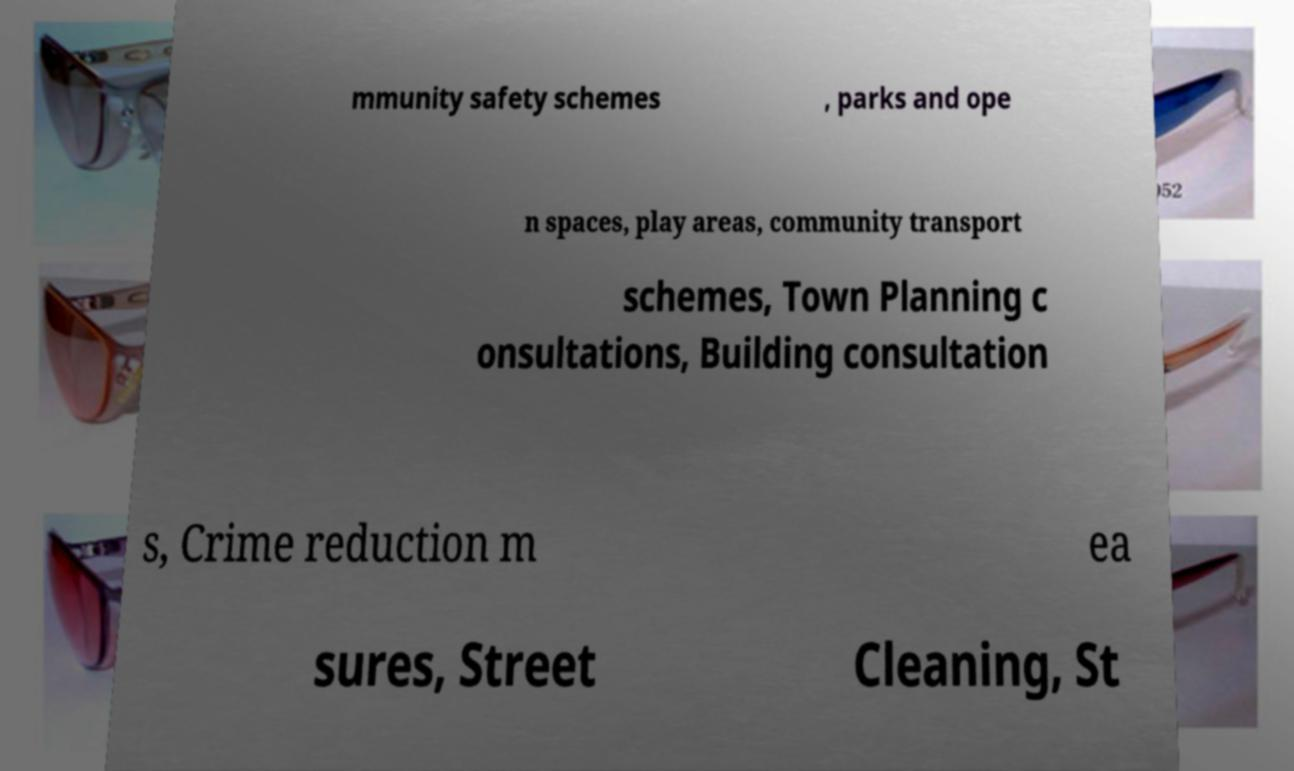Could you assist in decoding the text presented in this image and type it out clearly? mmunity safety schemes , parks and ope n spaces, play areas, community transport schemes, Town Planning c onsultations, Building consultation s, Crime reduction m ea sures, Street Cleaning, St 